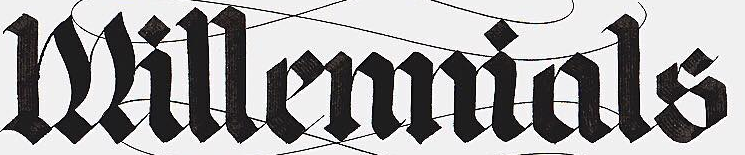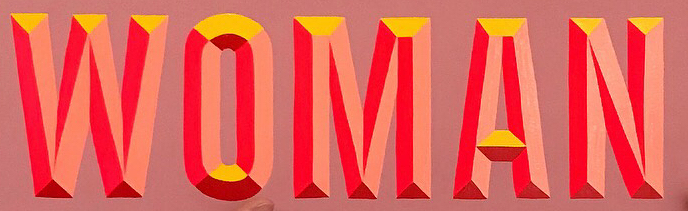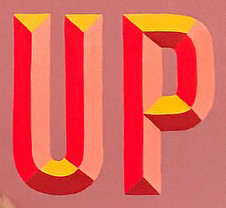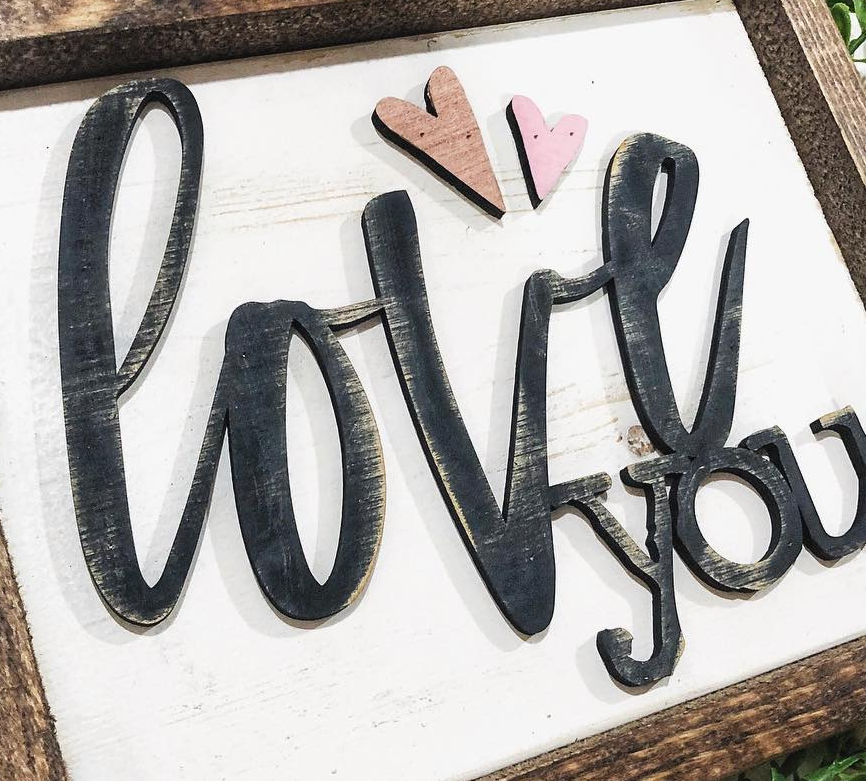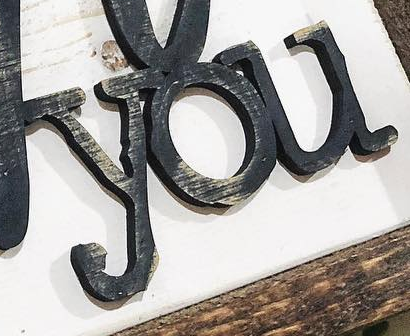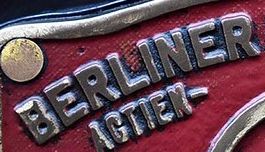What text appears in these images from left to right, separated by a semicolon? Millemmials; WOMAN; UP; love; you; BERLINER 